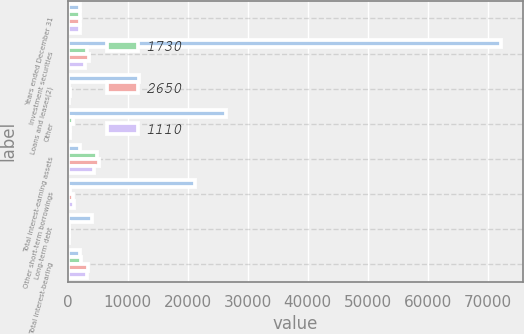<chart> <loc_0><loc_0><loc_500><loc_500><stacked_bar_chart><ecel><fcel>Years ended December 31<fcel>Investment securities<fcel>Loans and leases(2)<fcel>Other<fcel>Total interest-earning assets<fcel>Other short-term borrowings<fcel>Long-term debt<fcel>Total interest-bearing<nl><fcel>nan<fcel>2008<fcel>72227<fcel>11884<fcel>26426<fcel>2008<fcel>21283<fcel>4106<fcel>2008<nl><fcel>1730<fcel>2008<fcel>3163<fcel>276<fcel>838<fcel>4983<fcel>375<fcel>229<fcel>2229<nl><fcel>2650<fcel>2007<fcel>3649<fcel>394<fcel>471<fcel>5270<fcel>959<fcel>225<fcel>3482<nl><fcel>1110<fcel>2006<fcel>2956<fcel>288<fcel>462<fcel>4369<fcel>1145<fcel>178<fcel>3214<nl></chart> 